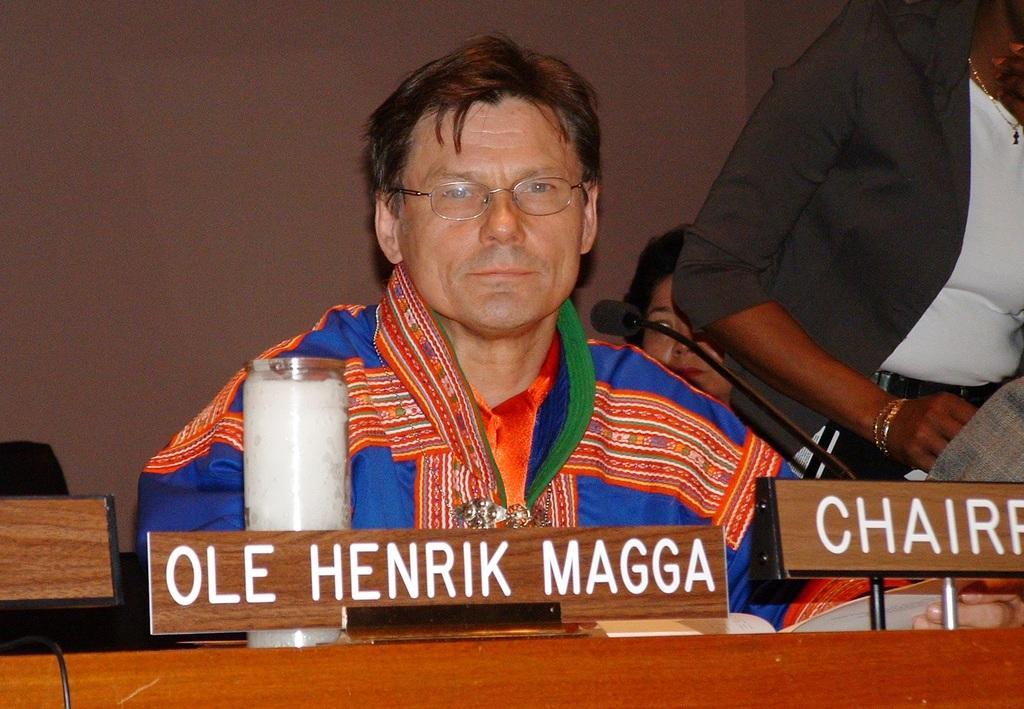Please provide a concise description of this image. There are two people sitting and he is holding a paper, beside him there is another person standing. We can see microphone, name boards and jar on the table. In the background we can see wall. 